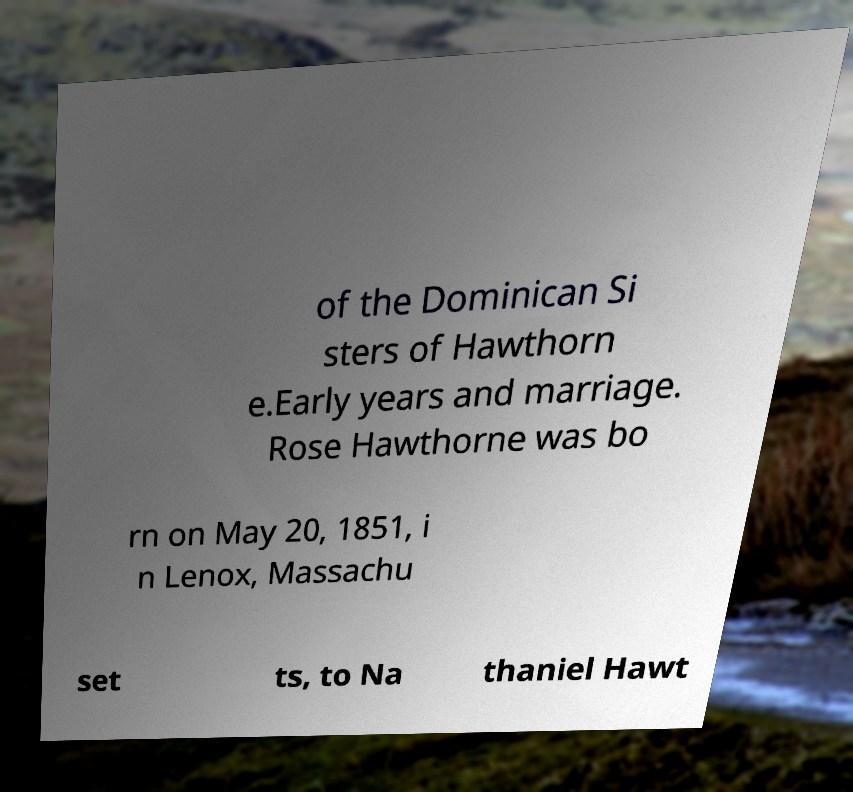There's text embedded in this image that I need extracted. Can you transcribe it verbatim? of the Dominican Si sters of Hawthorn e.Early years and marriage. Rose Hawthorne was bo rn on May 20, 1851, i n Lenox, Massachu set ts, to Na thaniel Hawt 